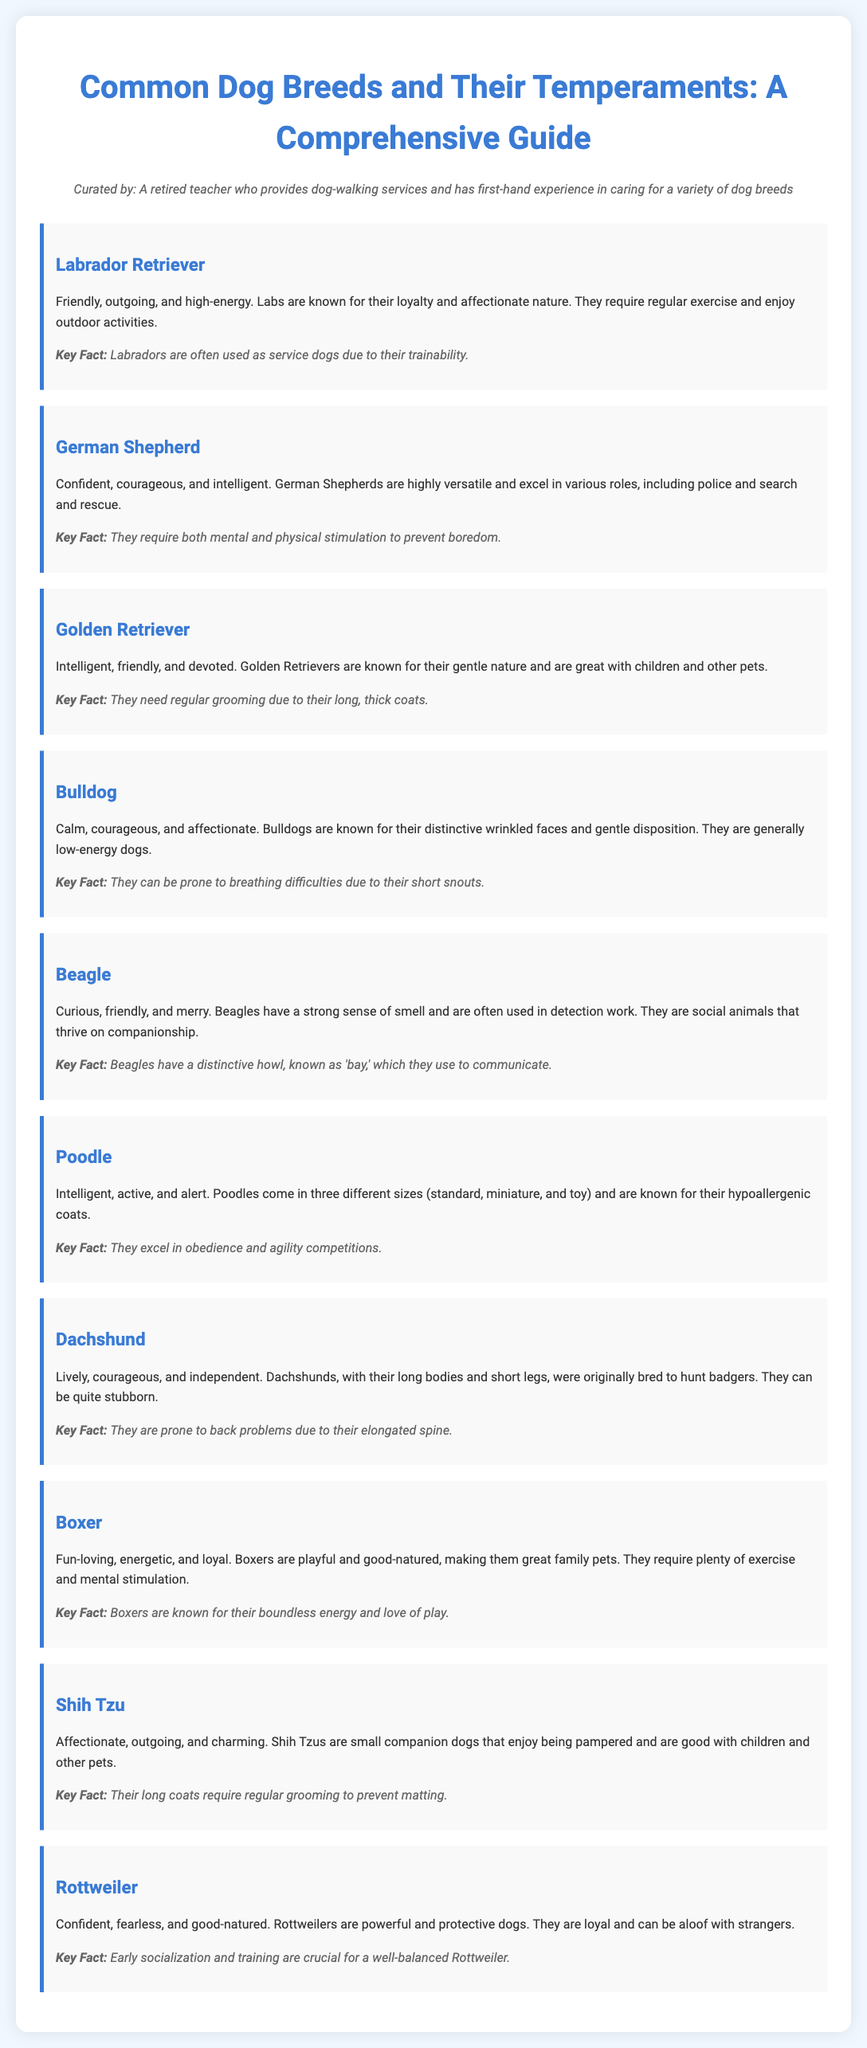What is the first breed listed? The first breed listed in the document is Labrador Retriever.
Answer: Labrador Retriever How many dog breeds are mentioned? The document mentions a total of ten dog breeds.
Answer: Ten Which breed is known for being good with children and other pets? The breed that is known for being good with children and other pets is the Golden Retriever.
Answer: Golden Retriever What is a key fact about Beagles? A key fact about Beagles is that they have a distinctive howl, known as 'bay.'
Answer: They have a distinctive howl, known as 'bay.' Which breed is described as low-energy? The breed described as low-energy is the Bulldog.
Answer: Bulldog What temperament is associated with Poodles? The temperament associated with Poodles is intelligent, active, and alert.
Answer: Intelligent, active, and alert How are Rottweilers described in terms of their nature towards strangers? Rottweilers are described as aloof with strangers.
Answer: Aloof What type of grooming do Shih Tzus require? Shih Tzus require regular grooming to prevent matting.
Answer: Regular grooming to prevent matting 